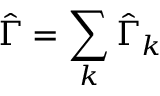Convert formula to latex. <formula><loc_0><loc_0><loc_500><loc_500>\hat { \Gamma } = \sum _ { k } \hat { \Gamma } _ { k }</formula> 